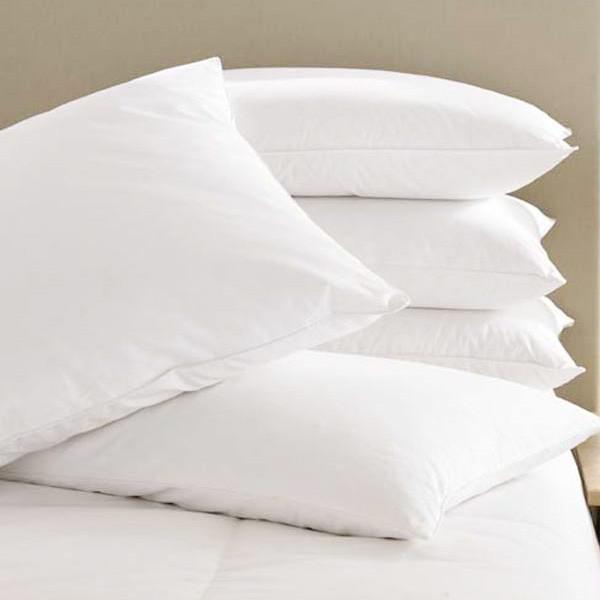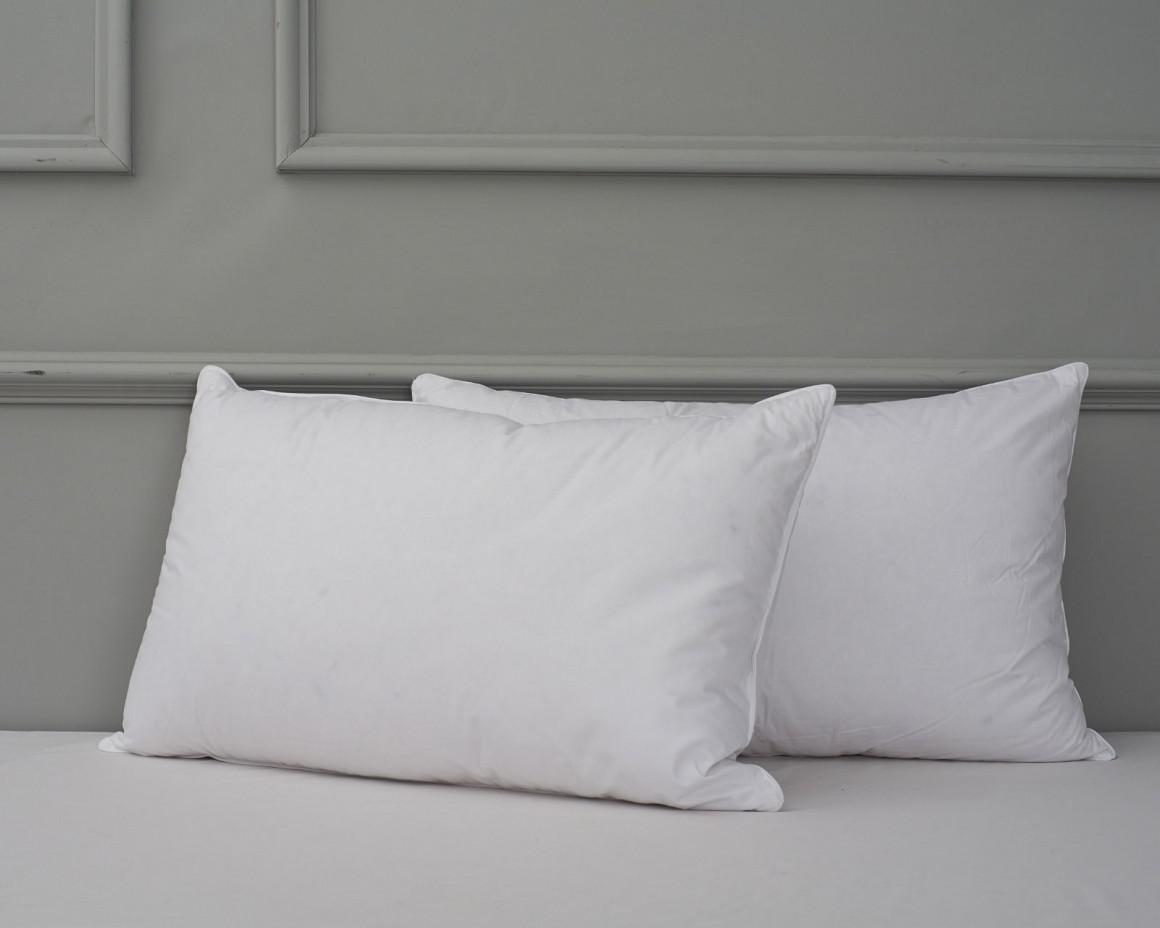The first image is the image on the left, the second image is the image on the right. For the images displayed, is the sentence "There are three or more white pillows that are resting on white mattresses." factually correct? Answer yes or no. Yes. The first image is the image on the left, the second image is the image on the right. Assess this claim about the two images: "There are three or fewer pillows.". Correct or not? Answer yes or no. No. 